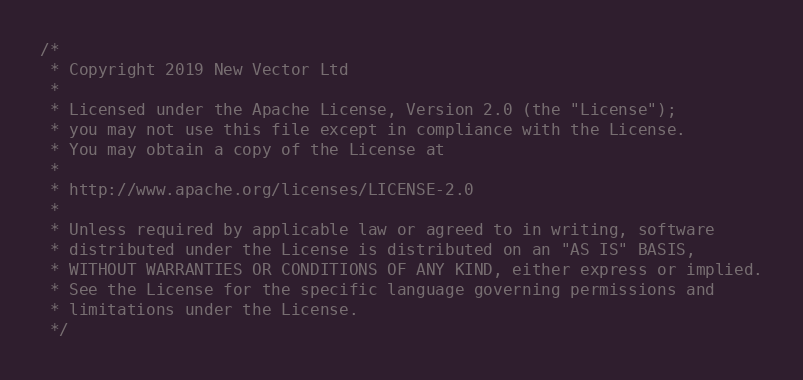Convert code to text. <code><loc_0><loc_0><loc_500><loc_500><_Kotlin_>/*
 * Copyright 2019 New Vector Ltd
 *
 * Licensed under the Apache License, Version 2.0 (the "License");
 * you may not use this file except in compliance with the License.
 * You may obtain a copy of the License at
 *
 * http://www.apache.org/licenses/LICENSE-2.0
 *
 * Unless required by applicable law or agreed to in writing, software
 * distributed under the License is distributed on an "AS IS" BASIS,
 * WITHOUT WARRANTIES OR CONDITIONS OF ANY KIND, either express or implied.
 * See the License for the specific language governing permissions and
 * limitations under the License.
 */
</code> 